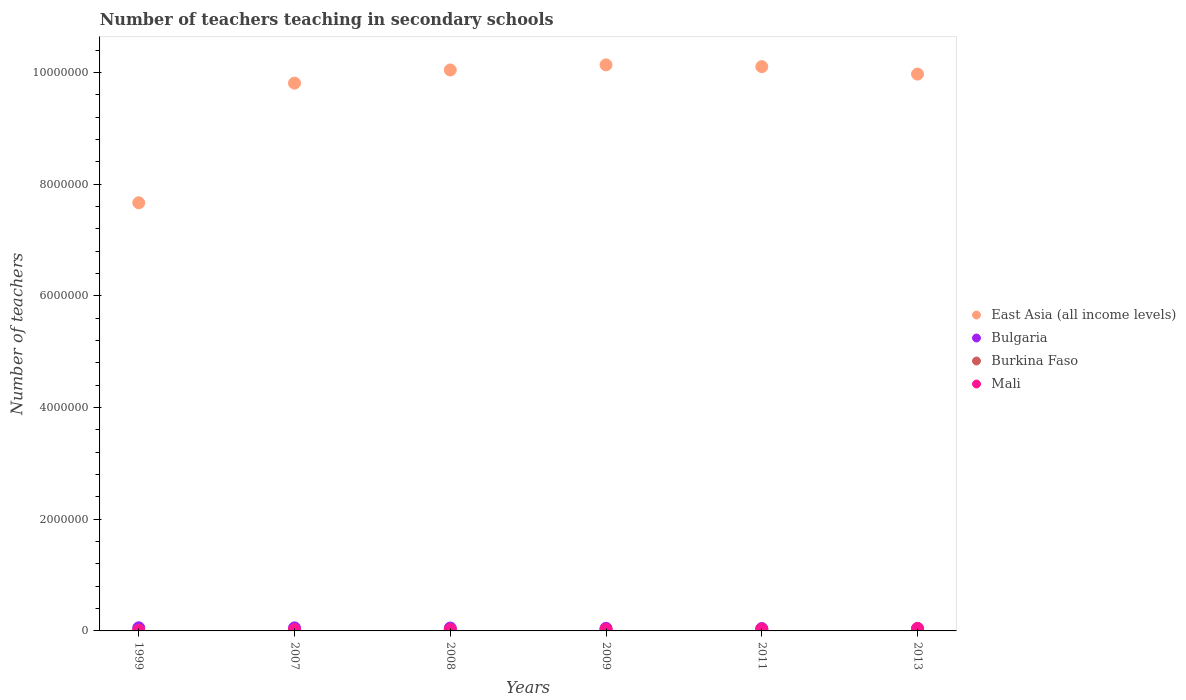Is the number of dotlines equal to the number of legend labels?
Provide a succinct answer. Yes. What is the number of teachers teaching in secondary schools in Burkina Faso in 2007?
Provide a succinct answer. 1.25e+04. Across all years, what is the maximum number of teachers teaching in secondary schools in East Asia (all income levels)?
Your response must be concise. 1.01e+07. Across all years, what is the minimum number of teachers teaching in secondary schools in Bulgaria?
Make the answer very short. 3.98e+04. In which year was the number of teachers teaching in secondary schools in Mali minimum?
Your answer should be very brief. 1999. What is the total number of teachers teaching in secondary schools in East Asia (all income levels) in the graph?
Your answer should be very brief. 5.77e+07. What is the difference between the number of teachers teaching in secondary schools in Bulgaria in 1999 and that in 2007?
Ensure brevity in your answer.  1168. What is the difference between the number of teachers teaching in secondary schools in East Asia (all income levels) in 2011 and the number of teachers teaching in secondary schools in Mali in 2013?
Your response must be concise. 1.01e+07. What is the average number of teachers teaching in secondary schools in Mali per year?
Give a very brief answer. 2.74e+04. In the year 2009, what is the difference between the number of teachers teaching in secondary schools in East Asia (all income levels) and number of teachers teaching in secondary schools in Mali?
Ensure brevity in your answer.  1.01e+07. What is the ratio of the number of teachers teaching in secondary schools in Mali in 2008 to that in 2013?
Ensure brevity in your answer.  0.57. Is the number of teachers teaching in secondary schools in Burkina Faso in 2008 less than that in 2009?
Your response must be concise. Yes. What is the difference between the highest and the second highest number of teachers teaching in secondary schools in Bulgaria?
Provide a succinct answer. 1168. What is the difference between the highest and the lowest number of teachers teaching in secondary schools in East Asia (all income levels)?
Offer a very short reply. 2.47e+06. In how many years, is the number of teachers teaching in secondary schools in East Asia (all income levels) greater than the average number of teachers teaching in secondary schools in East Asia (all income levels) taken over all years?
Provide a succinct answer. 5. Is the sum of the number of teachers teaching in secondary schools in Mali in 2007 and 2008 greater than the maximum number of teachers teaching in secondary schools in East Asia (all income levels) across all years?
Keep it short and to the point. No. Is the number of teachers teaching in secondary schools in Burkina Faso strictly less than the number of teachers teaching in secondary schools in Mali over the years?
Your answer should be compact. Yes. What is the difference between two consecutive major ticks on the Y-axis?
Ensure brevity in your answer.  2.00e+06. Does the graph contain any zero values?
Provide a succinct answer. No. What is the title of the graph?
Make the answer very short. Number of teachers teaching in secondary schools. Does "Portugal" appear as one of the legend labels in the graph?
Your answer should be very brief. No. What is the label or title of the Y-axis?
Ensure brevity in your answer.  Number of teachers. What is the Number of teachers in East Asia (all income levels) in 1999?
Give a very brief answer. 7.67e+06. What is the Number of teachers in Bulgaria in 1999?
Provide a short and direct response. 5.60e+04. What is the Number of teachers of Burkina Faso in 1999?
Ensure brevity in your answer.  6215. What is the Number of teachers in Mali in 1999?
Offer a very short reply. 7663. What is the Number of teachers of East Asia (all income levels) in 2007?
Offer a terse response. 9.81e+06. What is the Number of teachers in Bulgaria in 2007?
Your answer should be very brief. 5.48e+04. What is the Number of teachers of Burkina Faso in 2007?
Your answer should be very brief. 1.25e+04. What is the Number of teachers in Mali in 2007?
Provide a short and direct response. 2.23e+04. What is the Number of teachers of East Asia (all income levels) in 2008?
Make the answer very short. 1.00e+07. What is the Number of teachers in Bulgaria in 2008?
Keep it short and to the point. 5.17e+04. What is the Number of teachers of Burkina Faso in 2008?
Your answer should be very brief. 1.40e+04. What is the Number of teachers in Mali in 2008?
Give a very brief answer. 2.60e+04. What is the Number of teachers of East Asia (all income levels) in 2009?
Offer a terse response. 1.01e+07. What is the Number of teachers in Bulgaria in 2009?
Your response must be concise. 4.63e+04. What is the Number of teachers in Burkina Faso in 2009?
Make the answer very short. 1.83e+04. What is the Number of teachers of Mali in 2009?
Provide a succinct answer. 2.93e+04. What is the Number of teachers in East Asia (all income levels) in 2011?
Your response must be concise. 1.01e+07. What is the Number of teachers in Bulgaria in 2011?
Offer a very short reply. 4.26e+04. What is the Number of teachers in Burkina Faso in 2011?
Your response must be concise. 2.28e+04. What is the Number of teachers in Mali in 2011?
Give a very brief answer. 3.32e+04. What is the Number of teachers of East Asia (all income levels) in 2013?
Offer a terse response. 9.97e+06. What is the Number of teachers of Bulgaria in 2013?
Provide a succinct answer. 3.98e+04. What is the Number of teachers of Burkina Faso in 2013?
Your answer should be compact. 2.83e+04. What is the Number of teachers of Mali in 2013?
Give a very brief answer. 4.58e+04. Across all years, what is the maximum Number of teachers in East Asia (all income levels)?
Provide a succinct answer. 1.01e+07. Across all years, what is the maximum Number of teachers in Bulgaria?
Your answer should be compact. 5.60e+04. Across all years, what is the maximum Number of teachers of Burkina Faso?
Provide a succinct answer. 2.83e+04. Across all years, what is the maximum Number of teachers of Mali?
Your answer should be very brief. 4.58e+04. Across all years, what is the minimum Number of teachers of East Asia (all income levels)?
Give a very brief answer. 7.67e+06. Across all years, what is the minimum Number of teachers of Bulgaria?
Keep it short and to the point. 3.98e+04. Across all years, what is the minimum Number of teachers in Burkina Faso?
Your answer should be very brief. 6215. Across all years, what is the minimum Number of teachers of Mali?
Give a very brief answer. 7663. What is the total Number of teachers of East Asia (all income levels) in the graph?
Offer a very short reply. 5.77e+07. What is the total Number of teachers in Bulgaria in the graph?
Ensure brevity in your answer.  2.91e+05. What is the total Number of teachers in Burkina Faso in the graph?
Your answer should be compact. 1.02e+05. What is the total Number of teachers in Mali in the graph?
Give a very brief answer. 1.64e+05. What is the difference between the Number of teachers in East Asia (all income levels) in 1999 and that in 2007?
Offer a terse response. -2.14e+06. What is the difference between the Number of teachers of Bulgaria in 1999 and that in 2007?
Ensure brevity in your answer.  1168. What is the difference between the Number of teachers in Burkina Faso in 1999 and that in 2007?
Make the answer very short. -6283. What is the difference between the Number of teachers of Mali in 1999 and that in 2007?
Provide a short and direct response. -1.46e+04. What is the difference between the Number of teachers of East Asia (all income levels) in 1999 and that in 2008?
Give a very brief answer. -2.38e+06. What is the difference between the Number of teachers of Bulgaria in 1999 and that in 2008?
Offer a very short reply. 4281. What is the difference between the Number of teachers of Burkina Faso in 1999 and that in 2008?
Ensure brevity in your answer.  -7749. What is the difference between the Number of teachers in Mali in 1999 and that in 2008?
Your answer should be very brief. -1.83e+04. What is the difference between the Number of teachers of East Asia (all income levels) in 1999 and that in 2009?
Keep it short and to the point. -2.47e+06. What is the difference between the Number of teachers in Bulgaria in 1999 and that in 2009?
Make the answer very short. 9702. What is the difference between the Number of teachers of Burkina Faso in 1999 and that in 2009?
Keep it short and to the point. -1.20e+04. What is the difference between the Number of teachers of Mali in 1999 and that in 2009?
Make the answer very short. -2.16e+04. What is the difference between the Number of teachers in East Asia (all income levels) in 1999 and that in 2011?
Offer a terse response. -2.44e+06. What is the difference between the Number of teachers in Bulgaria in 1999 and that in 2011?
Provide a short and direct response. 1.34e+04. What is the difference between the Number of teachers of Burkina Faso in 1999 and that in 2011?
Your answer should be very brief. -1.66e+04. What is the difference between the Number of teachers of Mali in 1999 and that in 2011?
Your answer should be very brief. -2.56e+04. What is the difference between the Number of teachers of East Asia (all income levels) in 1999 and that in 2013?
Provide a short and direct response. -2.30e+06. What is the difference between the Number of teachers of Bulgaria in 1999 and that in 2013?
Your answer should be compact. 1.61e+04. What is the difference between the Number of teachers of Burkina Faso in 1999 and that in 2013?
Offer a terse response. -2.21e+04. What is the difference between the Number of teachers of Mali in 1999 and that in 2013?
Ensure brevity in your answer.  -3.81e+04. What is the difference between the Number of teachers in East Asia (all income levels) in 2007 and that in 2008?
Ensure brevity in your answer.  -2.35e+05. What is the difference between the Number of teachers in Bulgaria in 2007 and that in 2008?
Make the answer very short. 3113. What is the difference between the Number of teachers of Burkina Faso in 2007 and that in 2008?
Your answer should be very brief. -1466. What is the difference between the Number of teachers of Mali in 2007 and that in 2008?
Ensure brevity in your answer.  -3727. What is the difference between the Number of teachers in East Asia (all income levels) in 2007 and that in 2009?
Provide a succinct answer. -3.27e+05. What is the difference between the Number of teachers in Bulgaria in 2007 and that in 2009?
Offer a very short reply. 8534. What is the difference between the Number of teachers of Burkina Faso in 2007 and that in 2009?
Give a very brief answer. -5753. What is the difference between the Number of teachers of Mali in 2007 and that in 2009?
Provide a short and direct response. -7045. What is the difference between the Number of teachers of East Asia (all income levels) in 2007 and that in 2011?
Keep it short and to the point. -2.95e+05. What is the difference between the Number of teachers in Bulgaria in 2007 and that in 2011?
Ensure brevity in your answer.  1.23e+04. What is the difference between the Number of teachers of Burkina Faso in 2007 and that in 2011?
Provide a succinct answer. -1.03e+04. What is the difference between the Number of teachers of Mali in 2007 and that in 2011?
Your answer should be very brief. -1.10e+04. What is the difference between the Number of teachers of East Asia (all income levels) in 2007 and that in 2013?
Your answer should be very brief. -1.62e+05. What is the difference between the Number of teachers of Bulgaria in 2007 and that in 2013?
Offer a very short reply. 1.50e+04. What is the difference between the Number of teachers in Burkina Faso in 2007 and that in 2013?
Your answer should be compact. -1.58e+04. What is the difference between the Number of teachers in Mali in 2007 and that in 2013?
Provide a short and direct response. -2.35e+04. What is the difference between the Number of teachers in East Asia (all income levels) in 2008 and that in 2009?
Offer a very short reply. -9.17e+04. What is the difference between the Number of teachers of Bulgaria in 2008 and that in 2009?
Your answer should be very brief. 5421. What is the difference between the Number of teachers in Burkina Faso in 2008 and that in 2009?
Your answer should be compact. -4287. What is the difference between the Number of teachers in Mali in 2008 and that in 2009?
Give a very brief answer. -3318. What is the difference between the Number of teachers in East Asia (all income levels) in 2008 and that in 2011?
Give a very brief answer. -5.97e+04. What is the difference between the Number of teachers of Bulgaria in 2008 and that in 2011?
Offer a very short reply. 9143. What is the difference between the Number of teachers of Burkina Faso in 2008 and that in 2011?
Ensure brevity in your answer.  -8845. What is the difference between the Number of teachers of Mali in 2008 and that in 2011?
Your answer should be very brief. -7230. What is the difference between the Number of teachers of East Asia (all income levels) in 2008 and that in 2013?
Make the answer very short. 7.32e+04. What is the difference between the Number of teachers of Bulgaria in 2008 and that in 2013?
Your response must be concise. 1.19e+04. What is the difference between the Number of teachers of Burkina Faso in 2008 and that in 2013?
Provide a succinct answer. -1.44e+04. What is the difference between the Number of teachers of Mali in 2008 and that in 2013?
Offer a terse response. -1.98e+04. What is the difference between the Number of teachers of East Asia (all income levels) in 2009 and that in 2011?
Your answer should be compact. 3.20e+04. What is the difference between the Number of teachers of Bulgaria in 2009 and that in 2011?
Ensure brevity in your answer.  3722. What is the difference between the Number of teachers of Burkina Faso in 2009 and that in 2011?
Your answer should be very brief. -4558. What is the difference between the Number of teachers in Mali in 2009 and that in 2011?
Your answer should be compact. -3912. What is the difference between the Number of teachers in East Asia (all income levels) in 2009 and that in 2013?
Your answer should be very brief. 1.65e+05. What is the difference between the Number of teachers of Bulgaria in 2009 and that in 2013?
Your response must be concise. 6436. What is the difference between the Number of teachers in Burkina Faso in 2009 and that in 2013?
Offer a terse response. -1.01e+04. What is the difference between the Number of teachers of Mali in 2009 and that in 2013?
Your response must be concise. -1.65e+04. What is the difference between the Number of teachers of East Asia (all income levels) in 2011 and that in 2013?
Provide a short and direct response. 1.33e+05. What is the difference between the Number of teachers in Bulgaria in 2011 and that in 2013?
Give a very brief answer. 2714. What is the difference between the Number of teachers of Burkina Faso in 2011 and that in 2013?
Offer a very short reply. -5526. What is the difference between the Number of teachers in Mali in 2011 and that in 2013?
Offer a very short reply. -1.26e+04. What is the difference between the Number of teachers of East Asia (all income levels) in 1999 and the Number of teachers of Bulgaria in 2007?
Your response must be concise. 7.61e+06. What is the difference between the Number of teachers in East Asia (all income levels) in 1999 and the Number of teachers in Burkina Faso in 2007?
Provide a short and direct response. 7.65e+06. What is the difference between the Number of teachers in East Asia (all income levels) in 1999 and the Number of teachers in Mali in 2007?
Ensure brevity in your answer.  7.64e+06. What is the difference between the Number of teachers of Bulgaria in 1999 and the Number of teachers of Burkina Faso in 2007?
Provide a succinct answer. 4.35e+04. What is the difference between the Number of teachers of Bulgaria in 1999 and the Number of teachers of Mali in 2007?
Your response must be concise. 3.37e+04. What is the difference between the Number of teachers in Burkina Faso in 1999 and the Number of teachers in Mali in 2007?
Keep it short and to the point. -1.60e+04. What is the difference between the Number of teachers of East Asia (all income levels) in 1999 and the Number of teachers of Bulgaria in 2008?
Give a very brief answer. 7.61e+06. What is the difference between the Number of teachers of East Asia (all income levels) in 1999 and the Number of teachers of Burkina Faso in 2008?
Provide a succinct answer. 7.65e+06. What is the difference between the Number of teachers of East Asia (all income levels) in 1999 and the Number of teachers of Mali in 2008?
Keep it short and to the point. 7.64e+06. What is the difference between the Number of teachers in Bulgaria in 1999 and the Number of teachers in Burkina Faso in 2008?
Offer a very short reply. 4.20e+04. What is the difference between the Number of teachers of Bulgaria in 1999 and the Number of teachers of Mali in 2008?
Provide a short and direct response. 3.00e+04. What is the difference between the Number of teachers of Burkina Faso in 1999 and the Number of teachers of Mali in 2008?
Give a very brief answer. -1.98e+04. What is the difference between the Number of teachers of East Asia (all income levels) in 1999 and the Number of teachers of Bulgaria in 2009?
Offer a terse response. 7.62e+06. What is the difference between the Number of teachers of East Asia (all income levels) in 1999 and the Number of teachers of Burkina Faso in 2009?
Provide a succinct answer. 7.65e+06. What is the difference between the Number of teachers of East Asia (all income levels) in 1999 and the Number of teachers of Mali in 2009?
Offer a very short reply. 7.64e+06. What is the difference between the Number of teachers of Bulgaria in 1999 and the Number of teachers of Burkina Faso in 2009?
Provide a short and direct response. 3.77e+04. What is the difference between the Number of teachers of Bulgaria in 1999 and the Number of teachers of Mali in 2009?
Your answer should be very brief. 2.67e+04. What is the difference between the Number of teachers of Burkina Faso in 1999 and the Number of teachers of Mali in 2009?
Your answer should be compact. -2.31e+04. What is the difference between the Number of teachers in East Asia (all income levels) in 1999 and the Number of teachers in Bulgaria in 2011?
Provide a short and direct response. 7.62e+06. What is the difference between the Number of teachers in East Asia (all income levels) in 1999 and the Number of teachers in Burkina Faso in 2011?
Give a very brief answer. 7.64e+06. What is the difference between the Number of teachers of East Asia (all income levels) in 1999 and the Number of teachers of Mali in 2011?
Your answer should be compact. 7.63e+06. What is the difference between the Number of teachers in Bulgaria in 1999 and the Number of teachers in Burkina Faso in 2011?
Your response must be concise. 3.32e+04. What is the difference between the Number of teachers of Bulgaria in 1999 and the Number of teachers of Mali in 2011?
Your answer should be compact. 2.28e+04. What is the difference between the Number of teachers in Burkina Faso in 1999 and the Number of teachers in Mali in 2011?
Provide a succinct answer. -2.70e+04. What is the difference between the Number of teachers of East Asia (all income levels) in 1999 and the Number of teachers of Bulgaria in 2013?
Make the answer very short. 7.63e+06. What is the difference between the Number of teachers in East Asia (all income levels) in 1999 and the Number of teachers in Burkina Faso in 2013?
Your response must be concise. 7.64e+06. What is the difference between the Number of teachers of East Asia (all income levels) in 1999 and the Number of teachers of Mali in 2013?
Your response must be concise. 7.62e+06. What is the difference between the Number of teachers of Bulgaria in 1999 and the Number of teachers of Burkina Faso in 2013?
Make the answer very short. 2.76e+04. What is the difference between the Number of teachers of Bulgaria in 1999 and the Number of teachers of Mali in 2013?
Your answer should be compact. 1.02e+04. What is the difference between the Number of teachers in Burkina Faso in 1999 and the Number of teachers in Mali in 2013?
Keep it short and to the point. -3.96e+04. What is the difference between the Number of teachers in East Asia (all income levels) in 2007 and the Number of teachers in Bulgaria in 2008?
Your response must be concise. 9.76e+06. What is the difference between the Number of teachers of East Asia (all income levels) in 2007 and the Number of teachers of Burkina Faso in 2008?
Give a very brief answer. 9.79e+06. What is the difference between the Number of teachers of East Asia (all income levels) in 2007 and the Number of teachers of Mali in 2008?
Provide a succinct answer. 9.78e+06. What is the difference between the Number of teachers in Bulgaria in 2007 and the Number of teachers in Burkina Faso in 2008?
Offer a terse response. 4.08e+04. What is the difference between the Number of teachers in Bulgaria in 2007 and the Number of teachers in Mali in 2008?
Provide a short and direct response. 2.88e+04. What is the difference between the Number of teachers in Burkina Faso in 2007 and the Number of teachers in Mali in 2008?
Offer a very short reply. -1.35e+04. What is the difference between the Number of teachers in East Asia (all income levels) in 2007 and the Number of teachers in Bulgaria in 2009?
Provide a short and direct response. 9.76e+06. What is the difference between the Number of teachers in East Asia (all income levels) in 2007 and the Number of teachers in Burkina Faso in 2009?
Your response must be concise. 9.79e+06. What is the difference between the Number of teachers of East Asia (all income levels) in 2007 and the Number of teachers of Mali in 2009?
Ensure brevity in your answer.  9.78e+06. What is the difference between the Number of teachers of Bulgaria in 2007 and the Number of teachers of Burkina Faso in 2009?
Offer a terse response. 3.66e+04. What is the difference between the Number of teachers in Bulgaria in 2007 and the Number of teachers in Mali in 2009?
Offer a very short reply. 2.55e+04. What is the difference between the Number of teachers of Burkina Faso in 2007 and the Number of teachers of Mali in 2009?
Your answer should be very brief. -1.68e+04. What is the difference between the Number of teachers in East Asia (all income levels) in 2007 and the Number of teachers in Bulgaria in 2011?
Keep it short and to the point. 9.77e+06. What is the difference between the Number of teachers in East Asia (all income levels) in 2007 and the Number of teachers in Burkina Faso in 2011?
Provide a succinct answer. 9.79e+06. What is the difference between the Number of teachers in East Asia (all income levels) in 2007 and the Number of teachers in Mali in 2011?
Give a very brief answer. 9.78e+06. What is the difference between the Number of teachers in Bulgaria in 2007 and the Number of teachers in Burkina Faso in 2011?
Give a very brief answer. 3.20e+04. What is the difference between the Number of teachers of Bulgaria in 2007 and the Number of teachers of Mali in 2011?
Make the answer very short. 2.16e+04. What is the difference between the Number of teachers in Burkina Faso in 2007 and the Number of teachers in Mali in 2011?
Make the answer very short. -2.07e+04. What is the difference between the Number of teachers in East Asia (all income levels) in 2007 and the Number of teachers in Bulgaria in 2013?
Provide a short and direct response. 9.77e+06. What is the difference between the Number of teachers of East Asia (all income levels) in 2007 and the Number of teachers of Burkina Faso in 2013?
Offer a terse response. 9.78e+06. What is the difference between the Number of teachers of East Asia (all income levels) in 2007 and the Number of teachers of Mali in 2013?
Provide a short and direct response. 9.76e+06. What is the difference between the Number of teachers in Bulgaria in 2007 and the Number of teachers in Burkina Faso in 2013?
Offer a very short reply. 2.65e+04. What is the difference between the Number of teachers in Bulgaria in 2007 and the Number of teachers in Mali in 2013?
Keep it short and to the point. 9035. What is the difference between the Number of teachers in Burkina Faso in 2007 and the Number of teachers in Mali in 2013?
Provide a short and direct response. -3.33e+04. What is the difference between the Number of teachers in East Asia (all income levels) in 2008 and the Number of teachers in Bulgaria in 2009?
Your answer should be very brief. 1.00e+07. What is the difference between the Number of teachers in East Asia (all income levels) in 2008 and the Number of teachers in Burkina Faso in 2009?
Your answer should be very brief. 1.00e+07. What is the difference between the Number of teachers of East Asia (all income levels) in 2008 and the Number of teachers of Mali in 2009?
Offer a terse response. 1.00e+07. What is the difference between the Number of teachers of Bulgaria in 2008 and the Number of teachers of Burkina Faso in 2009?
Provide a succinct answer. 3.34e+04. What is the difference between the Number of teachers in Bulgaria in 2008 and the Number of teachers in Mali in 2009?
Make the answer very short. 2.24e+04. What is the difference between the Number of teachers in Burkina Faso in 2008 and the Number of teachers in Mali in 2009?
Keep it short and to the point. -1.53e+04. What is the difference between the Number of teachers of East Asia (all income levels) in 2008 and the Number of teachers of Bulgaria in 2011?
Provide a succinct answer. 1.00e+07. What is the difference between the Number of teachers of East Asia (all income levels) in 2008 and the Number of teachers of Burkina Faso in 2011?
Keep it short and to the point. 1.00e+07. What is the difference between the Number of teachers in East Asia (all income levels) in 2008 and the Number of teachers in Mali in 2011?
Offer a terse response. 1.00e+07. What is the difference between the Number of teachers of Bulgaria in 2008 and the Number of teachers of Burkina Faso in 2011?
Offer a terse response. 2.89e+04. What is the difference between the Number of teachers of Bulgaria in 2008 and the Number of teachers of Mali in 2011?
Make the answer very short. 1.85e+04. What is the difference between the Number of teachers in Burkina Faso in 2008 and the Number of teachers in Mali in 2011?
Offer a very short reply. -1.93e+04. What is the difference between the Number of teachers of East Asia (all income levels) in 2008 and the Number of teachers of Bulgaria in 2013?
Your answer should be compact. 1.00e+07. What is the difference between the Number of teachers in East Asia (all income levels) in 2008 and the Number of teachers in Burkina Faso in 2013?
Your response must be concise. 1.00e+07. What is the difference between the Number of teachers of East Asia (all income levels) in 2008 and the Number of teachers of Mali in 2013?
Ensure brevity in your answer.  1.00e+07. What is the difference between the Number of teachers in Bulgaria in 2008 and the Number of teachers in Burkina Faso in 2013?
Your answer should be very brief. 2.34e+04. What is the difference between the Number of teachers of Bulgaria in 2008 and the Number of teachers of Mali in 2013?
Your answer should be compact. 5922. What is the difference between the Number of teachers of Burkina Faso in 2008 and the Number of teachers of Mali in 2013?
Keep it short and to the point. -3.18e+04. What is the difference between the Number of teachers of East Asia (all income levels) in 2009 and the Number of teachers of Bulgaria in 2011?
Make the answer very short. 1.01e+07. What is the difference between the Number of teachers in East Asia (all income levels) in 2009 and the Number of teachers in Burkina Faso in 2011?
Your answer should be very brief. 1.01e+07. What is the difference between the Number of teachers of East Asia (all income levels) in 2009 and the Number of teachers of Mali in 2011?
Ensure brevity in your answer.  1.01e+07. What is the difference between the Number of teachers in Bulgaria in 2009 and the Number of teachers in Burkina Faso in 2011?
Give a very brief answer. 2.35e+04. What is the difference between the Number of teachers in Bulgaria in 2009 and the Number of teachers in Mali in 2011?
Ensure brevity in your answer.  1.31e+04. What is the difference between the Number of teachers in Burkina Faso in 2009 and the Number of teachers in Mali in 2011?
Give a very brief answer. -1.50e+04. What is the difference between the Number of teachers of East Asia (all income levels) in 2009 and the Number of teachers of Bulgaria in 2013?
Make the answer very short. 1.01e+07. What is the difference between the Number of teachers in East Asia (all income levels) in 2009 and the Number of teachers in Burkina Faso in 2013?
Offer a terse response. 1.01e+07. What is the difference between the Number of teachers of East Asia (all income levels) in 2009 and the Number of teachers of Mali in 2013?
Make the answer very short. 1.01e+07. What is the difference between the Number of teachers of Bulgaria in 2009 and the Number of teachers of Burkina Faso in 2013?
Your response must be concise. 1.79e+04. What is the difference between the Number of teachers in Bulgaria in 2009 and the Number of teachers in Mali in 2013?
Your answer should be very brief. 501. What is the difference between the Number of teachers of Burkina Faso in 2009 and the Number of teachers of Mali in 2013?
Your answer should be compact. -2.75e+04. What is the difference between the Number of teachers in East Asia (all income levels) in 2011 and the Number of teachers in Bulgaria in 2013?
Your answer should be very brief. 1.01e+07. What is the difference between the Number of teachers in East Asia (all income levels) in 2011 and the Number of teachers in Burkina Faso in 2013?
Offer a very short reply. 1.01e+07. What is the difference between the Number of teachers in East Asia (all income levels) in 2011 and the Number of teachers in Mali in 2013?
Your answer should be very brief. 1.01e+07. What is the difference between the Number of teachers in Bulgaria in 2011 and the Number of teachers in Burkina Faso in 2013?
Your answer should be very brief. 1.42e+04. What is the difference between the Number of teachers of Bulgaria in 2011 and the Number of teachers of Mali in 2013?
Your answer should be compact. -3221. What is the difference between the Number of teachers in Burkina Faso in 2011 and the Number of teachers in Mali in 2013?
Provide a succinct answer. -2.30e+04. What is the average Number of teachers in East Asia (all income levels) per year?
Offer a very short reply. 9.62e+06. What is the average Number of teachers of Bulgaria per year?
Offer a very short reply. 4.85e+04. What is the average Number of teachers in Burkina Faso per year?
Offer a terse response. 1.70e+04. What is the average Number of teachers in Mali per year?
Your answer should be compact. 2.74e+04. In the year 1999, what is the difference between the Number of teachers in East Asia (all income levels) and Number of teachers in Bulgaria?
Offer a very short reply. 7.61e+06. In the year 1999, what is the difference between the Number of teachers of East Asia (all income levels) and Number of teachers of Burkina Faso?
Provide a succinct answer. 7.66e+06. In the year 1999, what is the difference between the Number of teachers in East Asia (all income levels) and Number of teachers in Mali?
Provide a succinct answer. 7.66e+06. In the year 1999, what is the difference between the Number of teachers of Bulgaria and Number of teachers of Burkina Faso?
Your answer should be compact. 4.98e+04. In the year 1999, what is the difference between the Number of teachers in Bulgaria and Number of teachers in Mali?
Provide a succinct answer. 4.83e+04. In the year 1999, what is the difference between the Number of teachers in Burkina Faso and Number of teachers in Mali?
Offer a very short reply. -1448. In the year 2007, what is the difference between the Number of teachers in East Asia (all income levels) and Number of teachers in Bulgaria?
Offer a very short reply. 9.75e+06. In the year 2007, what is the difference between the Number of teachers of East Asia (all income levels) and Number of teachers of Burkina Faso?
Give a very brief answer. 9.80e+06. In the year 2007, what is the difference between the Number of teachers of East Asia (all income levels) and Number of teachers of Mali?
Give a very brief answer. 9.79e+06. In the year 2007, what is the difference between the Number of teachers of Bulgaria and Number of teachers of Burkina Faso?
Keep it short and to the point. 4.23e+04. In the year 2007, what is the difference between the Number of teachers of Bulgaria and Number of teachers of Mali?
Your response must be concise. 3.26e+04. In the year 2007, what is the difference between the Number of teachers in Burkina Faso and Number of teachers in Mali?
Provide a short and direct response. -9765. In the year 2008, what is the difference between the Number of teachers in East Asia (all income levels) and Number of teachers in Bulgaria?
Provide a short and direct response. 9.99e+06. In the year 2008, what is the difference between the Number of teachers in East Asia (all income levels) and Number of teachers in Burkina Faso?
Provide a short and direct response. 1.00e+07. In the year 2008, what is the difference between the Number of teachers of East Asia (all income levels) and Number of teachers of Mali?
Provide a short and direct response. 1.00e+07. In the year 2008, what is the difference between the Number of teachers in Bulgaria and Number of teachers in Burkina Faso?
Offer a very short reply. 3.77e+04. In the year 2008, what is the difference between the Number of teachers of Bulgaria and Number of teachers of Mali?
Make the answer very short. 2.57e+04. In the year 2008, what is the difference between the Number of teachers of Burkina Faso and Number of teachers of Mali?
Give a very brief answer. -1.20e+04. In the year 2009, what is the difference between the Number of teachers of East Asia (all income levels) and Number of teachers of Bulgaria?
Your answer should be compact. 1.01e+07. In the year 2009, what is the difference between the Number of teachers of East Asia (all income levels) and Number of teachers of Burkina Faso?
Give a very brief answer. 1.01e+07. In the year 2009, what is the difference between the Number of teachers in East Asia (all income levels) and Number of teachers in Mali?
Your answer should be compact. 1.01e+07. In the year 2009, what is the difference between the Number of teachers in Bulgaria and Number of teachers in Burkina Faso?
Your answer should be very brief. 2.80e+04. In the year 2009, what is the difference between the Number of teachers of Bulgaria and Number of teachers of Mali?
Your answer should be compact. 1.70e+04. In the year 2009, what is the difference between the Number of teachers in Burkina Faso and Number of teachers in Mali?
Your answer should be compact. -1.11e+04. In the year 2011, what is the difference between the Number of teachers of East Asia (all income levels) and Number of teachers of Bulgaria?
Give a very brief answer. 1.01e+07. In the year 2011, what is the difference between the Number of teachers of East Asia (all income levels) and Number of teachers of Burkina Faso?
Give a very brief answer. 1.01e+07. In the year 2011, what is the difference between the Number of teachers of East Asia (all income levels) and Number of teachers of Mali?
Your response must be concise. 1.01e+07. In the year 2011, what is the difference between the Number of teachers in Bulgaria and Number of teachers in Burkina Faso?
Ensure brevity in your answer.  1.97e+04. In the year 2011, what is the difference between the Number of teachers of Bulgaria and Number of teachers of Mali?
Offer a very short reply. 9337. In the year 2011, what is the difference between the Number of teachers of Burkina Faso and Number of teachers of Mali?
Make the answer very short. -1.04e+04. In the year 2013, what is the difference between the Number of teachers in East Asia (all income levels) and Number of teachers in Bulgaria?
Your response must be concise. 9.93e+06. In the year 2013, what is the difference between the Number of teachers in East Asia (all income levels) and Number of teachers in Burkina Faso?
Your response must be concise. 9.94e+06. In the year 2013, what is the difference between the Number of teachers of East Asia (all income levels) and Number of teachers of Mali?
Your answer should be very brief. 9.92e+06. In the year 2013, what is the difference between the Number of teachers of Bulgaria and Number of teachers of Burkina Faso?
Your response must be concise. 1.15e+04. In the year 2013, what is the difference between the Number of teachers of Bulgaria and Number of teachers of Mali?
Provide a succinct answer. -5935. In the year 2013, what is the difference between the Number of teachers in Burkina Faso and Number of teachers in Mali?
Keep it short and to the point. -1.74e+04. What is the ratio of the Number of teachers in East Asia (all income levels) in 1999 to that in 2007?
Offer a terse response. 0.78. What is the ratio of the Number of teachers of Bulgaria in 1999 to that in 2007?
Ensure brevity in your answer.  1.02. What is the ratio of the Number of teachers in Burkina Faso in 1999 to that in 2007?
Provide a succinct answer. 0.5. What is the ratio of the Number of teachers in Mali in 1999 to that in 2007?
Your response must be concise. 0.34. What is the ratio of the Number of teachers of East Asia (all income levels) in 1999 to that in 2008?
Keep it short and to the point. 0.76. What is the ratio of the Number of teachers of Bulgaria in 1999 to that in 2008?
Offer a terse response. 1.08. What is the ratio of the Number of teachers of Burkina Faso in 1999 to that in 2008?
Provide a short and direct response. 0.45. What is the ratio of the Number of teachers in Mali in 1999 to that in 2008?
Ensure brevity in your answer.  0.29. What is the ratio of the Number of teachers of East Asia (all income levels) in 1999 to that in 2009?
Offer a terse response. 0.76. What is the ratio of the Number of teachers of Bulgaria in 1999 to that in 2009?
Make the answer very short. 1.21. What is the ratio of the Number of teachers of Burkina Faso in 1999 to that in 2009?
Your answer should be compact. 0.34. What is the ratio of the Number of teachers in Mali in 1999 to that in 2009?
Your response must be concise. 0.26. What is the ratio of the Number of teachers in East Asia (all income levels) in 1999 to that in 2011?
Provide a short and direct response. 0.76. What is the ratio of the Number of teachers in Bulgaria in 1999 to that in 2011?
Your answer should be very brief. 1.32. What is the ratio of the Number of teachers of Burkina Faso in 1999 to that in 2011?
Your answer should be very brief. 0.27. What is the ratio of the Number of teachers in Mali in 1999 to that in 2011?
Offer a very short reply. 0.23. What is the ratio of the Number of teachers of East Asia (all income levels) in 1999 to that in 2013?
Ensure brevity in your answer.  0.77. What is the ratio of the Number of teachers of Bulgaria in 1999 to that in 2013?
Your answer should be compact. 1.41. What is the ratio of the Number of teachers in Burkina Faso in 1999 to that in 2013?
Make the answer very short. 0.22. What is the ratio of the Number of teachers in Mali in 1999 to that in 2013?
Provide a short and direct response. 0.17. What is the ratio of the Number of teachers of East Asia (all income levels) in 2007 to that in 2008?
Keep it short and to the point. 0.98. What is the ratio of the Number of teachers of Bulgaria in 2007 to that in 2008?
Keep it short and to the point. 1.06. What is the ratio of the Number of teachers in Burkina Faso in 2007 to that in 2008?
Offer a terse response. 0.9. What is the ratio of the Number of teachers of Mali in 2007 to that in 2008?
Your answer should be compact. 0.86. What is the ratio of the Number of teachers of East Asia (all income levels) in 2007 to that in 2009?
Keep it short and to the point. 0.97. What is the ratio of the Number of teachers in Bulgaria in 2007 to that in 2009?
Keep it short and to the point. 1.18. What is the ratio of the Number of teachers in Burkina Faso in 2007 to that in 2009?
Offer a very short reply. 0.68. What is the ratio of the Number of teachers in Mali in 2007 to that in 2009?
Your answer should be very brief. 0.76. What is the ratio of the Number of teachers in East Asia (all income levels) in 2007 to that in 2011?
Your response must be concise. 0.97. What is the ratio of the Number of teachers in Bulgaria in 2007 to that in 2011?
Your answer should be compact. 1.29. What is the ratio of the Number of teachers in Burkina Faso in 2007 to that in 2011?
Ensure brevity in your answer.  0.55. What is the ratio of the Number of teachers in Mali in 2007 to that in 2011?
Your answer should be compact. 0.67. What is the ratio of the Number of teachers of East Asia (all income levels) in 2007 to that in 2013?
Your response must be concise. 0.98. What is the ratio of the Number of teachers in Bulgaria in 2007 to that in 2013?
Offer a very short reply. 1.38. What is the ratio of the Number of teachers of Burkina Faso in 2007 to that in 2013?
Keep it short and to the point. 0.44. What is the ratio of the Number of teachers of Mali in 2007 to that in 2013?
Your answer should be very brief. 0.49. What is the ratio of the Number of teachers in Bulgaria in 2008 to that in 2009?
Your response must be concise. 1.12. What is the ratio of the Number of teachers in Burkina Faso in 2008 to that in 2009?
Your answer should be compact. 0.77. What is the ratio of the Number of teachers of Mali in 2008 to that in 2009?
Keep it short and to the point. 0.89. What is the ratio of the Number of teachers of Bulgaria in 2008 to that in 2011?
Provide a short and direct response. 1.21. What is the ratio of the Number of teachers in Burkina Faso in 2008 to that in 2011?
Keep it short and to the point. 0.61. What is the ratio of the Number of teachers of Mali in 2008 to that in 2011?
Give a very brief answer. 0.78. What is the ratio of the Number of teachers of East Asia (all income levels) in 2008 to that in 2013?
Make the answer very short. 1.01. What is the ratio of the Number of teachers of Bulgaria in 2008 to that in 2013?
Your answer should be compact. 1.3. What is the ratio of the Number of teachers in Burkina Faso in 2008 to that in 2013?
Ensure brevity in your answer.  0.49. What is the ratio of the Number of teachers of Mali in 2008 to that in 2013?
Your response must be concise. 0.57. What is the ratio of the Number of teachers in Bulgaria in 2009 to that in 2011?
Your answer should be very brief. 1.09. What is the ratio of the Number of teachers of Burkina Faso in 2009 to that in 2011?
Provide a short and direct response. 0.8. What is the ratio of the Number of teachers in Mali in 2009 to that in 2011?
Ensure brevity in your answer.  0.88. What is the ratio of the Number of teachers of East Asia (all income levels) in 2009 to that in 2013?
Your answer should be compact. 1.02. What is the ratio of the Number of teachers in Bulgaria in 2009 to that in 2013?
Offer a terse response. 1.16. What is the ratio of the Number of teachers in Burkina Faso in 2009 to that in 2013?
Provide a short and direct response. 0.64. What is the ratio of the Number of teachers in Mali in 2009 to that in 2013?
Keep it short and to the point. 0.64. What is the ratio of the Number of teachers of East Asia (all income levels) in 2011 to that in 2013?
Provide a succinct answer. 1.01. What is the ratio of the Number of teachers of Bulgaria in 2011 to that in 2013?
Your answer should be very brief. 1.07. What is the ratio of the Number of teachers in Burkina Faso in 2011 to that in 2013?
Keep it short and to the point. 0.81. What is the ratio of the Number of teachers of Mali in 2011 to that in 2013?
Ensure brevity in your answer.  0.73. What is the difference between the highest and the second highest Number of teachers in East Asia (all income levels)?
Keep it short and to the point. 3.20e+04. What is the difference between the highest and the second highest Number of teachers of Bulgaria?
Your response must be concise. 1168. What is the difference between the highest and the second highest Number of teachers of Burkina Faso?
Your answer should be very brief. 5526. What is the difference between the highest and the second highest Number of teachers of Mali?
Your response must be concise. 1.26e+04. What is the difference between the highest and the lowest Number of teachers of East Asia (all income levels)?
Keep it short and to the point. 2.47e+06. What is the difference between the highest and the lowest Number of teachers of Bulgaria?
Your response must be concise. 1.61e+04. What is the difference between the highest and the lowest Number of teachers in Burkina Faso?
Offer a very short reply. 2.21e+04. What is the difference between the highest and the lowest Number of teachers in Mali?
Your answer should be compact. 3.81e+04. 